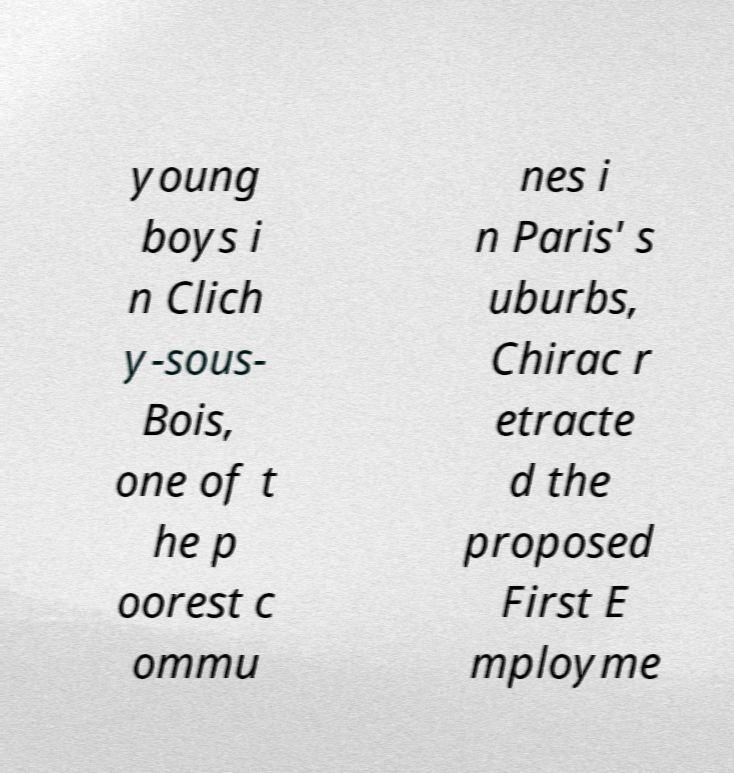I need the written content from this picture converted into text. Can you do that? young boys i n Clich y-sous- Bois, one of t he p oorest c ommu nes i n Paris' s uburbs, Chirac r etracte d the proposed First E mployme 